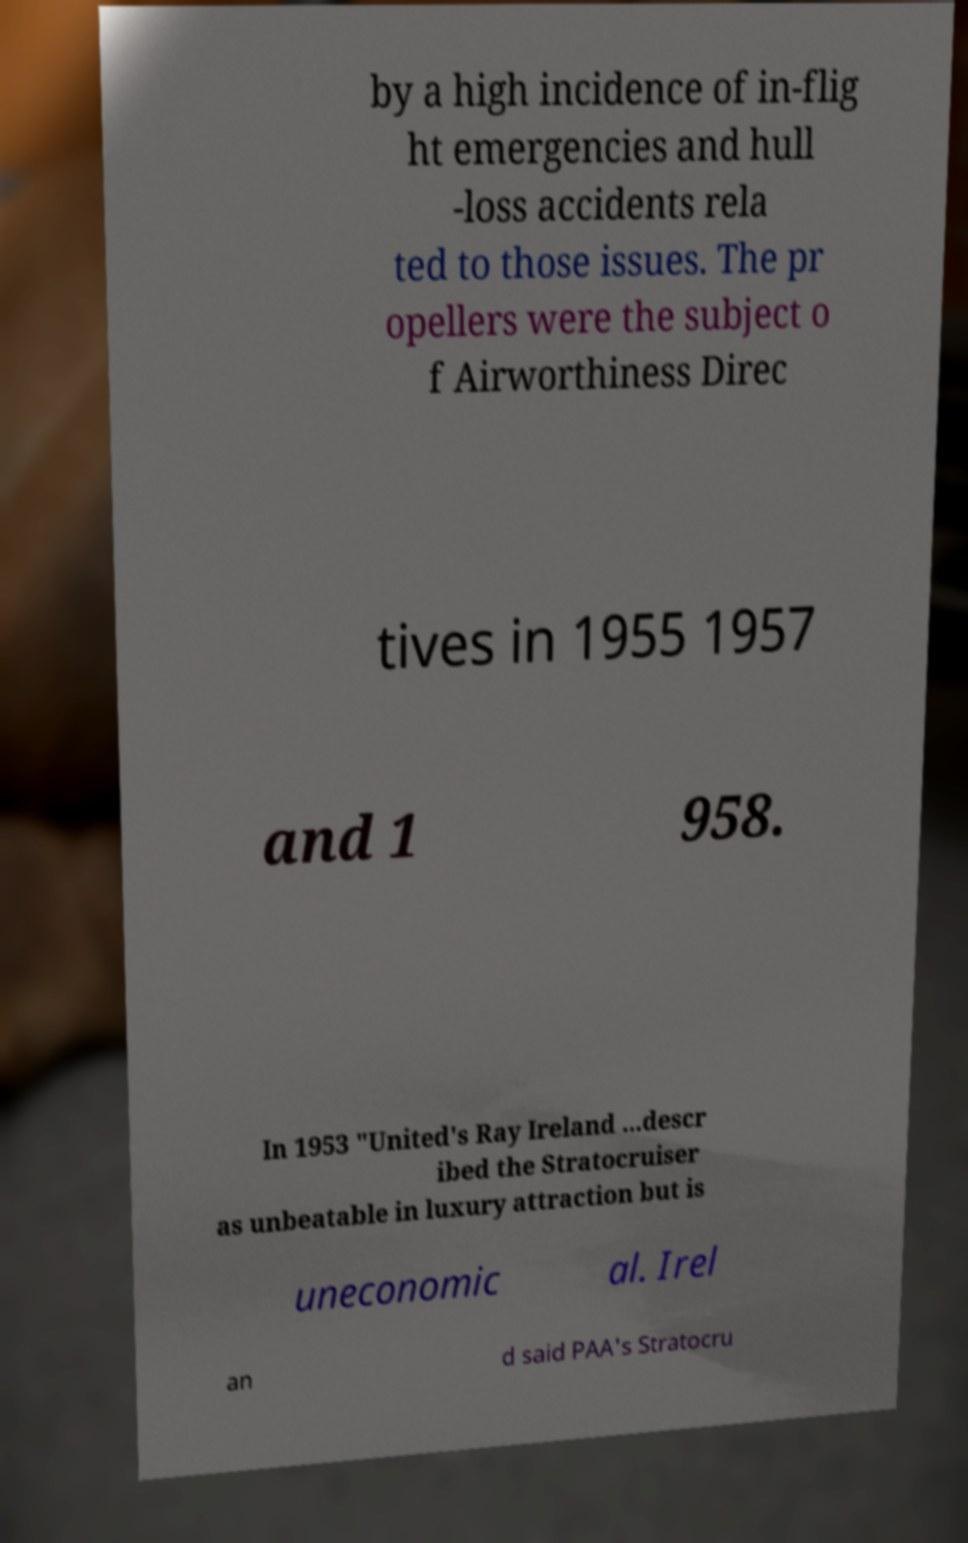There's text embedded in this image that I need extracted. Can you transcribe it verbatim? by a high incidence of in-flig ht emergencies and hull -loss accidents rela ted to those issues. The pr opellers were the subject o f Airworthiness Direc tives in 1955 1957 and 1 958. In 1953 "United's Ray Ireland ...descr ibed the Stratocruiser as unbeatable in luxury attraction but is uneconomic al. Irel an d said PAA's Stratocru 